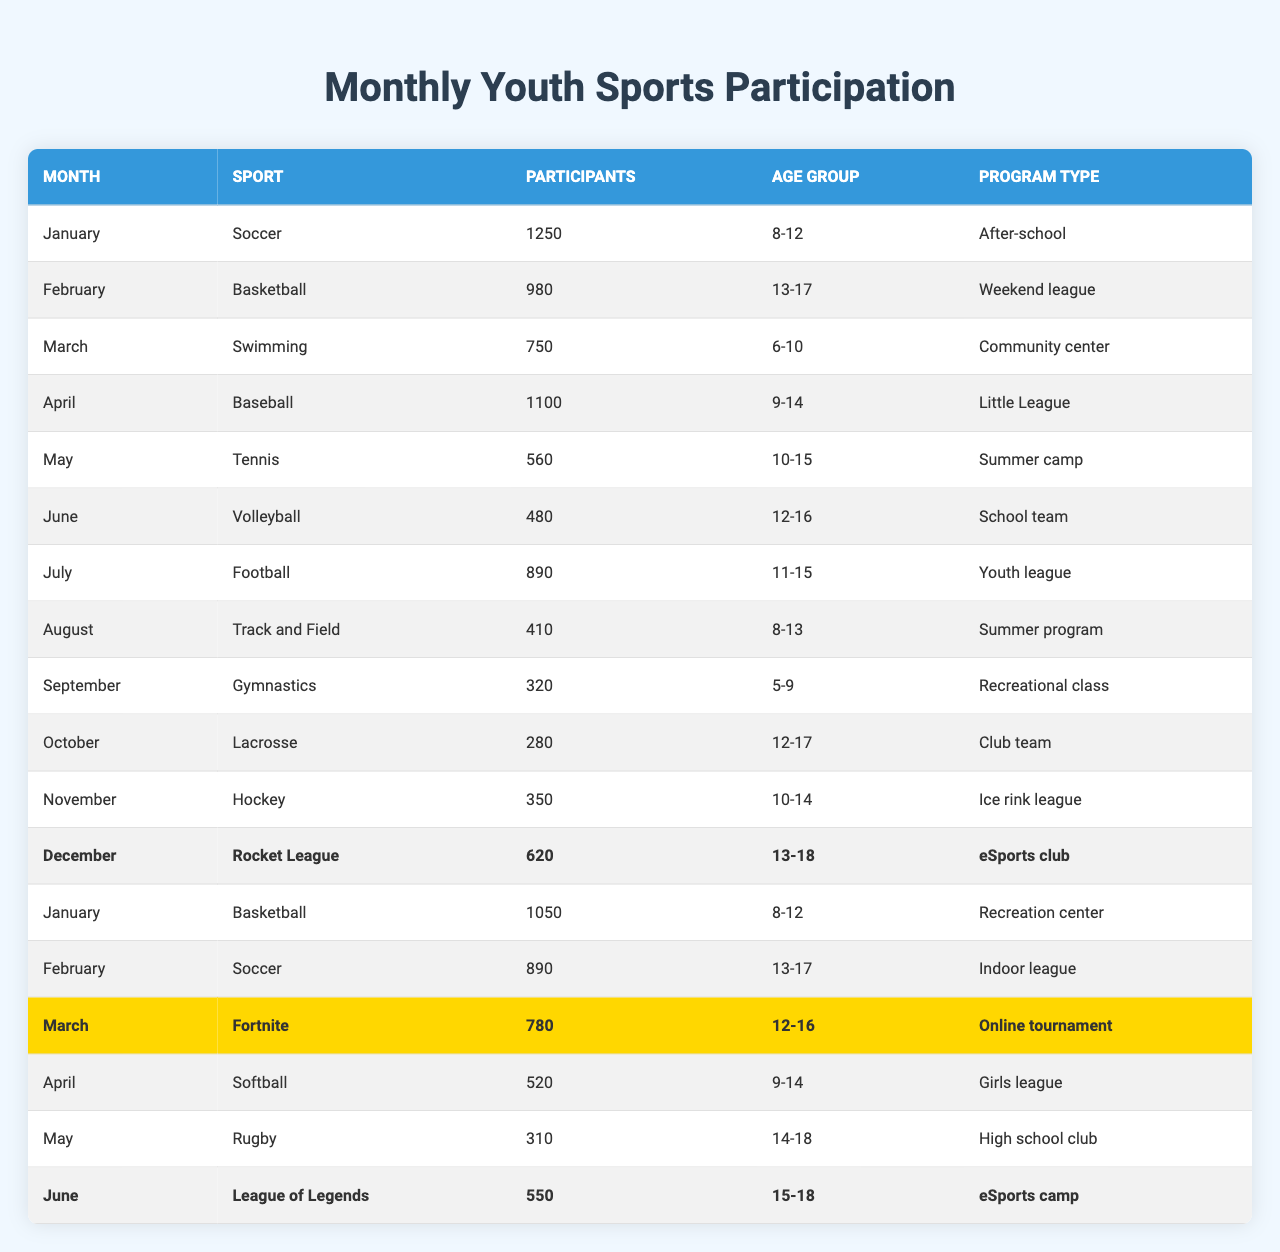What sport had the highest participation in January? In January, soccer had 1250 participants, which is higher than basketball's 1050 participants. Therefore, soccer had the highest participation in January.
Answer: Soccer Which age group participated the most in football activities? The age group 11-15 participated in football activities in July, with 890 participants. This is the only entry for football in the table, so this group had the most participants.
Answer: 11-15 What is the total number of participants who played tennis and rugby over the year? Tennis had 560 participants in May, and rugby had 310 participants in May. The total is 560 + 310 = 870.
Answer: 870 Was the participation in eSports programs, like Rocket League, higher than in traditional sports, like gymnastics? Rocket League had 620 participants in December, while gymnastics had 320 participants in September; thus, participation in Rocket League was indeed higher than gymnastics.
Answer: Yes What was the average number of participants for baseball and softball in April? Baseball had 1100 participants in April, and softball had 520 participants in the same month. The average is calculated as (1100 + 520) / 2 = 810.
Answer: 810 Which month had the least number of participants in any youth sports program? September had the least number of participants, with gymnastics recording only 320 participants. No other month has a lower participation number.
Answer: September If you combine the participants from March for swimming and Fortnite, what is the total? Swimming had 750 participants in March, and Fortnite had 780 participants in March. Adding the two gives 750 + 780 = 1530 total participants for March.
Answer: 1530 What percentage of participants in June were under the age of 16? In June, volleyball (480 participants) was for ages 12-16, and League of Legends (550 participants) was for ages 15-18. Summing them gives 1030 participants, all of whom are under 16. The percentage is (1030/total participants in June)*100, but there are only these two entries in June, so the percentage is 100%.
Answer: 100% In which month did participation in soccer drop compared to the previous month? In February, the participation in soccer was 890, which is lower than the 1250 participants recorded in January, indicating a drop in participation.
Answer: February Which sport had more participants: Lacrosse or hockey? Lacrosse had 280 participants in October, while hockey had 350 participants in November. Therefore, hockey had more participants than Lacrosse.
Answer: Hockey 